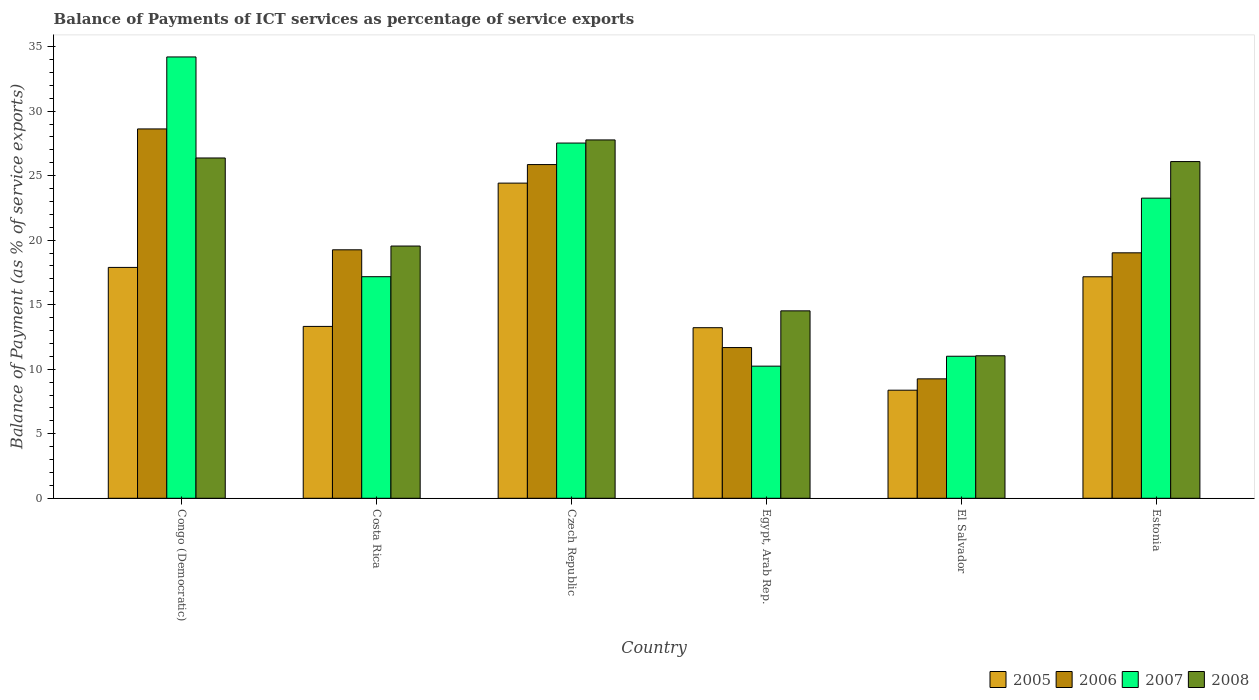Are the number of bars per tick equal to the number of legend labels?
Keep it short and to the point. Yes. How many bars are there on the 6th tick from the right?
Your answer should be very brief. 4. What is the label of the 1st group of bars from the left?
Your response must be concise. Congo (Democratic). In how many cases, is the number of bars for a given country not equal to the number of legend labels?
Make the answer very short. 0. What is the balance of payments of ICT services in 2006 in Costa Rica?
Offer a terse response. 19.25. Across all countries, what is the maximum balance of payments of ICT services in 2007?
Provide a succinct answer. 34.2. Across all countries, what is the minimum balance of payments of ICT services in 2007?
Provide a short and direct response. 10.24. In which country was the balance of payments of ICT services in 2008 maximum?
Offer a very short reply. Czech Republic. In which country was the balance of payments of ICT services in 2005 minimum?
Offer a terse response. El Salvador. What is the total balance of payments of ICT services in 2005 in the graph?
Offer a very short reply. 94.39. What is the difference between the balance of payments of ICT services in 2006 in Czech Republic and that in Estonia?
Keep it short and to the point. 6.84. What is the difference between the balance of payments of ICT services in 2008 in Congo (Democratic) and the balance of payments of ICT services in 2007 in El Salvador?
Keep it short and to the point. 15.36. What is the average balance of payments of ICT services in 2007 per country?
Your answer should be compact. 20.57. What is the difference between the balance of payments of ICT services of/in 2008 and balance of payments of ICT services of/in 2007 in Costa Rica?
Your answer should be very brief. 2.38. What is the ratio of the balance of payments of ICT services in 2008 in Czech Republic to that in Egypt, Arab Rep.?
Offer a terse response. 1.91. Is the balance of payments of ICT services in 2007 in Congo (Democratic) less than that in El Salvador?
Provide a succinct answer. No. What is the difference between the highest and the second highest balance of payments of ICT services in 2005?
Your response must be concise. 6.53. What is the difference between the highest and the lowest balance of payments of ICT services in 2006?
Provide a succinct answer. 19.37. What does the 4th bar from the right in Costa Rica represents?
Provide a short and direct response. 2005. Is it the case that in every country, the sum of the balance of payments of ICT services in 2008 and balance of payments of ICT services in 2007 is greater than the balance of payments of ICT services in 2006?
Make the answer very short. Yes. How many bars are there?
Your answer should be very brief. 24. Are all the bars in the graph horizontal?
Offer a very short reply. No. What is the difference between two consecutive major ticks on the Y-axis?
Give a very brief answer. 5. Does the graph contain any zero values?
Your response must be concise. No. Does the graph contain grids?
Offer a very short reply. No. How are the legend labels stacked?
Provide a succinct answer. Horizontal. What is the title of the graph?
Your response must be concise. Balance of Payments of ICT services as percentage of service exports. What is the label or title of the X-axis?
Offer a terse response. Country. What is the label or title of the Y-axis?
Your answer should be very brief. Balance of Payment (as % of service exports). What is the Balance of Payment (as % of service exports) of 2005 in Congo (Democratic)?
Keep it short and to the point. 17.89. What is the Balance of Payment (as % of service exports) in 2006 in Congo (Democratic)?
Your response must be concise. 28.62. What is the Balance of Payment (as % of service exports) of 2007 in Congo (Democratic)?
Offer a terse response. 34.2. What is the Balance of Payment (as % of service exports) in 2008 in Congo (Democratic)?
Your answer should be very brief. 26.37. What is the Balance of Payment (as % of service exports) in 2005 in Costa Rica?
Offer a terse response. 13.32. What is the Balance of Payment (as % of service exports) of 2006 in Costa Rica?
Offer a very short reply. 19.25. What is the Balance of Payment (as % of service exports) in 2007 in Costa Rica?
Provide a succinct answer. 17.17. What is the Balance of Payment (as % of service exports) of 2008 in Costa Rica?
Offer a terse response. 19.55. What is the Balance of Payment (as % of service exports) in 2005 in Czech Republic?
Ensure brevity in your answer.  24.42. What is the Balance of Payment (as % of service exports) in 2006 in Czech Republic?
Offer a very short reply. 25.86. What is the Balance of Payment (as % of service exports) in 2007 in Czech Republic?
Offer a very short reply. 27.53. What is the Balance of Payment (as % of service exports) of 2008 in Czech Republic?
Provide a short and direct response. 27.77. What is the Balance of Payment (as % of service exports) in 2005 in Egypt, Arab Rep.?
Give a very brief answer. 13.22. What is the Balance of Payment (as % of service exports) in 2006 in Egypt, Arab Rep.?
Provide a succinct answer. 11.68. What is the Balance of Payment (as % of service exports) of 2007 in Egypt, Arab Rep.?
Give a very brief answer. 10.24. What is the Balance of Payment (as % of service exports) of 2008 in Egypt, Arab Rep.?
Offer a very short reply. 14.52. What is the Balance of Payment (as % of service exports) in 2005 in El Salvador?
Your response must be concise. 8.38. What is the Balance of Payment (as % of service exports) of 2006 in El Salvador?
Ensure brevity in your answer.  9.25. What is the Balance of Payment (as % of service exports) in 2007 in El Salvador?
Offer a very short reply. 11.01. What is the Balance of Payment (as % of service exports) of 2008 in El Salvador?
Give a very brief answer. 11.04. What is the Balance of Payment (as % of service exports) of 2005 in Estonia?
Your answer should be compact. 17.16. What is the Balance of Payment (as % of service exports) of 2006 in Estonia?
Provide a succinct answer. 19.02. What is the Balance of Payment (as % of service exports) of 2007 in Estonia?
Make the answer very short. 23.26. What is the Balance of Payment (as % of service exports) in 2008 in Estonia?
Offer a very short reply. 26.09. Across all countries, what is the maximum Balance of Payment (as % of service exports) of 2005?
Keep it short and to the point. 24.42. Across all countries, what is the maximum Balance of Payment (as % of service exports) in 2006?
Your response must be concise. 28.62. Across all countries, what is the maximum Balance of Payment (as % of service exports) in 2007?
Ensure brevity in your answer.  34.2. Across all countries, what is the maximum Balance of Payment (as % of service exports) of 2008?
Ensure brevity in your answer.  27.77. Across all countries, what is the minimum Balance of Payment (as % of service exports) of 2005?
Keep it short and to the point. 8.38. Across all countries, what is the minimum Balance of Payment (as % of service exports) of 2006?
Offer a very short reply. 9.25. Across all countries, what is the minimum Balance of Payment (as % of service exports) of 2007?
Your answer should be compact. 10.24. Across all countries, what is the minimum Balance of Payment (as % of service exports) in 2008?
Offer a very short reply. 11.04. What is the total Balance of Payment (as % of service exports) in 2005 in the graph?
Keep it short and to the point. 94.39. What is the total Balance of Payment (as % of service exports) in 2006 in the graph?
Your answer should be very brief. 113.69. What is the total Balance of Payment (as % of service exports) of 2007 in the graph?
Offer a very short reply. 123.4. What is the total Balance of Payment (as % of service exports) in 2008 in the graph?
Make the answer very short. 125.35. What is the difference between the Balance of Payment (as % of service exports) in 2005 in Congo (Democratic) and that in Costa Rica?
Provide a short and direct response. 4.57. What is the difference between the Balance of Payment (as % of service exports) of 2006 in Congo (Democratic) and that in Costa Rica?
Keep it short and to the point. 9.37. What is the difference between the Balance of Payment (as % of service exports) of 2007 in Congo (Democratic) and that in Costa Rica?
Provide a short and direct response. 17.03. What is the difference between the Balance of Payment (as % of service exports) in 2008 in Congo (Democratic) and that in Costa Rica?
Provide a succinct answer. 6.82. What is the difference between the Balance of Payment (as % of service exports) of 2005 in Congo (Democratic) and that in Czech Republic?
Your answer should be compact. -6.53. What is the difference between the Balance of Payment (as % of service exports) of 2006 in Congo (Democratic) and that in Czech Republic?
Your response must be concise. 2.76. What is the difference between the Balance of Payment (as % of service exports) of 2007 in Congo (Democratic) and that in Czech Republic?
Your answer should be very brief. 6.67. What is the difference between the Balance of Payment (as % of service exports) of 2008 in Congo (Democratic) and that in Czech Republic?
Offer a very short reply. -1.4. What is the difference between the Balance of Payment (as % of service exports) in 2005 in Congo (Democratic) and that in Egypt, Arab Rep.?
Your answer should be compact. 4.67. What is the difference between the Balance of Payment (as % of service exports) in 2006 in Congo (Democratic) and that in Egypt, Arab Rep.?
Give a very brief answer. 16.94. What is the difference between the Balance of Payment (as % of service exports) in 2007 in Congo (Democratic) and that in Egypt, Arab Rep.?
Your response must be concise. 23.96. What is the difference between the Balance of Payment (as % of service exports) of 2008 in Congo (Democratic) and that in Egypt, Arab Rep.?
Your response must be concise. 11.85. What is the difference between the Balance of Payment (as % of service exports) in 2005 in Congo (Democratic) and that in El Salvador?
Provide a short and direct response. 9.51. What is the difference between the Balance of Payment (as % of service exports) of 2006 in Congo (Democratic) and that in El Salvador?
Your response must be concise. 19.37. What is the difference between the Balance of Payment (as % of service exports) in 2007 in Congo (Democratic) and that in El Salvador?
Give a very brief answer. 23.19. What is the difference between the Balance of Payment (as % of service exports) of 2008 in Congo (Democratic) and that in El Salvador?
Provide a succinct answer. 15.33. What is the difference between the Balance of Payment (as % of service exports) in 2005 in Congo (Democratic) and that in Estonia?
Make the answer very short. 0.73. What is the difference between the Balance of Payment (as % of service exports) in 2006 in Congo (Democratic) and that in Estonia?
Your response must be concise. 9.6. What is the difference between the Balance of Payment (as % of service exports) of 2007 in Congo (Democratic) and that in Estonia?
Offer a very short reply. 10.94. What is the difference between the Balance of Payment (as % of service exports) of 2008 in Congo (Democratic) and that in Estonia?
Your response must be concise. 0.28. What is the difference between the Balance of Payment (as % of service exports) of 2005 in Costa Rica and that in Czech Republic?
Keep it short and to the point. -11.1. What is the difference between the Balance of Payment (as % of service exports) in 2006 in Costa Rica and that in Czech Republic?
Make the answer very short. -6.6. What is the difference between the Balance of Payment (as % of service exports) of 2007 in Costa Rica and that in Czech Republic?
Ensure brevity in your answer.  -10.36. What is the difference between the Balance of Payment (as % of service exports) of 2008 in Costa Rica and that in Czech Republic?
Ensure brevity in your answer.  -8.22. What is the difference between the Balance of Payment (as % of service exports) of 2005 in Costa Rica and that in Egypt, Arab Rep.?
Provide a succinct answer. 0.1. What is the difference between the Balance of Payment (as % of service exports) in 2006 in Costa Rica and that in Egypt, Arab Rep.?
Ensure brevity in your answer.  7.57. What is the difference between the Balance of Payment (as % of service exports) in 2007 in Costa Rica and that in Egypt, Arab Rep.?
Your answer should be very brief. 6.93. What is the difference between the Balance of Payment (as % of service exports) in 2008 in Costa Rica and that in Egypt, Arab Rep.?
Offer a very short reply. 5.02. What is the difference between the Balance of Payment (as % of service exports) in 2005 in Costa Rica and that in El Salvador?
Your answer should be compact. 4.94. What is the difference between the Balance of Payment (as % of service exports) in 2006 in Costa Rica and that in El Salvador?
Give a very brief answer. 10. What is the difference between the Balance of Payment (as % of service exports) in 2007 in Costa Rica and that in El Salvador?
Your response must be concise. 6.16. What is the difference between the Balance of Payment (as % of service exports) of 2008 in Costa Rica and that in El Salvador?
Provide a succinct answer. 8.5. What is the difference between the Balance of Payment (as % of service exports) in 2005 in Costa Rica and that in Estonia?
Make the answer very short. -3.85. What is the difference between the Balance of Payment (as % of service exports) of 2006 in Costa Rica and that in Estonia?
Ensure brevity in your answer.  0.23. What is the difference between the Balance of Payment (as % of service exports) in 2007 in Costa Rica and that in Estonia?
Your answer should be compact. -6.09. What is the difference between the Balance of Payment (as % of service exports) of 2008 in Costa Rica and that in Estonia?
Keep it short and to the point. -6.55. What is the difference between the Balance of Payment (as % of service exports) of 2005 in Czech Republic and that in Egypt, Arab Rep.?
Your answer should be compact. 11.2. What is the difference between the Balance of Payment (as % of service exports) in 2006 in Czech Republic and that in Egypt, Arab Rep.?
Keep it short and to the point. 14.18. What is the difference between the Balance of Payment (as % of service exports) of 2007 in Czech Republic and that in Egypt, Arab Rep.?
Your response must be concise. 17.29. What is the difference between the Balance of Payment (as % of service exports) of 2008 in Czech Republic and that in Egypt, Arab Rep.?
Your answer should be very brief. 13.24. What is the difference between the Balance of Payment (as % of service exports) of 2005 in Czech Republic and that in El Salvador?
Keep it short and to the point. 16.05. What is the difference between the Balance of Payment (as % of service exports) in 2006 in Czech Republic and that in El Salvador?
Your answer should be very brief. 16.6. What is the difference between the Balance of Payment (as % of service exports) of 2007 in Czech Republic and that in El Salvador?
Make the answer very short. 16.52. What is the difference between the Balance of Payment (as % of service exports) in 2008 in Czech Republic and that in El Salvador?
Make the answer very short. 16.73. What is the difference between the Balance of Payment (as % of service exports) of 2005 in Czech Republic and that in Estonia?
Provide a short and direct response. 7.26. What is the difference between the Balance of Payment (as % of service exports) of 2006 in Czech Republic and that in Estonia?
Provide a succinct answer. 6.84. What is the difference between the Balance of Payment (as % of service exports) in 2007 in Czech Republic and that in Estonia?
Provide a short and direct response. 4.27. What is the difference between the Balance of Payment (as % of service exports) in 2008 in Czech Republic and that in Estonia?
Make the answer very short. 1.68. What is the difference between the Balance of Payment (as % of service exports) of 2005 in Egypt, Arab Rep. and that in El Salvador?
Your answer should be very brief. 4.84. What is the difference between the Balance of Payment (as % of service exports) in 2006 in Egypt, Arab Rep. and that in El Salvador?
Your response must be concise. 2.43. What is the difference between the Balance of Payment (as % of service exports) of 2007 in Egypt, Arab Rep. and that in El Salvador?
Provide a short and direct response. -0.77. What is the difference between the Balance of Payment (as % of service exports) in 2008 in Egypt, Arab Rep. and that in El Salvador?
Provide a succinct answer. 3.48. What is the difference between the Balance of Payment (as % of service exports) in 2005 in Egypt, Arab Rep. and that in Estonia?
Give a very brief answer. -3.95. What is the difference between the Balance of Payment (as % of service exports) of 2006 in Egypt, Arab Rep. and that in Estonia?
Offer a terse response. -7.34. What is the difference between the Balance of Payment (as % of service exports) of 2007 in Egypt, Arab Rep. and that in Estonia?
Keep it short and to the point. -13.02. What is the difference between the Balance of Payment (as % of service exports) of 2008 in Egypt, Arab Rep. and that in Estonia?
Keep it short and to the point. -11.57. What is the difference between the Balance of Payment (as % of service exports) of 2005 in El Salvador and that in Estonia?
Your answer should be compact. -8.79. What is the difference between the Balance of Payment (as % of service exports) in 2006 in El Salvador and that in Estonia?
Give a very brief answer. -9.77. What is the difference between the Balance of Payment (as % of service exports) in 2007 in El Salvador and that in Estonia?
Ensure brevity in your answer.  -12.25. What is the difference between the Balance of Payment (as % of service exports) in 2008 in El Salvador and that in Estonia?
Your answer should be compact. -15.05. What is the difference between the Balance of Payment (as % of service exports) in 2005 in Congo (Democratic) and the Balance of Payment (as % of service exports) in 2006 in Costa Rica?
Provide a short and direct response. -1.36. What is the difference between the Balance of Payment (as % of service exports) in 2005 in Congo (Democratic) and the Balance of Payment (as % of service exports) in 2007 in Costa Rica?
Ensure brevity in your answer.  0.72. What is the difference between the Balance of Payment (as % of service exports) of 2005 in Congo (Democratic) and the Balance of Payment (as % of service exports) of 2008 in Costa Rica?
Ensure brevity in your answer.  -1.66. What is the difference between the Balance of Payment (as % of service exports) of 2006 in Congo (Democratic) and the Balance of Payment (as % of service exports) of 2007 in Costa Rica?
Make the answer very short. 11.45. What is the difference between the Balance of Payment (as % of service exports) in 2006 in Congo (Democratic) and the Balance of Payment (as % of service exports) in 2008 in Costa Rica?
Give a very brief answer. 9.07. What is the difference between the Balance of Payment (as % of service exports) of 2007 in Congo (Democratic) and the Balance of Payment (as % of service exports) of 2008 in Costa Rica?
Offer a terse response. 14.65. What is the difference between the Balance of Payment (as % of service exports) in 2005 in Congo (Democratic) and the Balance of Payment (as % of service exports) in 2006 in Czech Republic?
Your answer should be compact. -7.97. What is the difference between the Balance of Payment (as % of service exports) in 2005 in Congo (Democratic) and the Balance of Payment (as % of service exports) in 2007 in Czech Republic?
Make the answer very short. -9.64. What is the difference between the Balance of Payment (as % of service exports) in 2005 in Congo (Democratic) and the Balance of Payment (as % of service exports) in 2008 in Czech Republic?
Your response must be concise. -9.88. What is the difference between the Balance of Payment (as % of service exports) of 2006 in Congo (Democratic) and the Balance of Payment (as % of service exports) of 2007 in Czech Republic?
Provide a succinct answer. 1.09. What is the difference between the Balance of Payment (as % of service exports) in 2006 in Congo (Democratic) and the Balance of Payment (as % of service exports) in 2008 in Czech Republic?
Provide a succinct answer. 0.85. What is the difference between the Balance of Payment (as % of service exports) of 2007 in Congo (Democratic) and the Balance of Payment (as % of service exports) of 2008 in Czech Republic?
Keep it short and to the point. 6.43. What is the difference between the Balance of Payment (as % of service exports) of 2005 in Congo (Democratic) and the Balance of Payment (as % of service exports) of 2006 in Egypt, Arab Rep.?
Ensure brevity in your answer.  6.21. What is the difference between the Balance of Payment (as % of service exports) in 2005 in Congo (Democratic) and the Balance of Payment (as % of service exports) in 2007 in Egypt, Arab Rep.?
Ensure brevity in your answer.  7.65. What is the difference between the Balance of Payment (as % of service exports) in 2005 in Congo (Democratic) and the Balance of Payment (as % of service exports) in 2008 in Egypt, Arab Rep.?
Keep it short and to the point. 3.37. What is the difference between the Balance of Payment (as % of service exports) of 2006 in Congo (Democratic) and the Balance of Payment (as % of service exports) of 2007 in Egypt, Arab Rep.?
Offer a terse response. 18.38. What is the difference between the Balance of Payment (as % of service exports) in 2006 in Congo (Democratic) and the Balance of Payment (as % of service exports) in 2008 in Egypt, Arab Rep.?
Your response must be concise. 14.1. What is the difference between the Balance of Payment (as % of service exports) in 2007 in Congo (Democratic) and the Balance of Payment (as % of service exports) in 2008 in Egypt, Arab Rep.?
Give a very brief answer. 19.68. What is the difference between the Balance of Payment (as % of service exports) in 2005 in Congo (Democratic) and the Balance of Payment (as % of service exports) in 2006 in El Salvador?
Ensure brevity in your answer.  8.64. What is the difference between the Balance of Payment (as % of service exports) of 2005 in Congo (Democratic) and the Balance of Payment (as % of service exports) of 2007 in El Salvador?
Your response must be concise. 6.88. What is the difference between the Balance of Payment (as % of service exports) of 2005 in Congo (Democratic) and the Balance of Payment (as % of service exports) of 2008 in El Salvador?
Offer a very short reply. 6.85. What is the difference between the Balance of Payment (as % of service exports) of 2006 in Congo (Democratic) and the Balance of Payment (as % of service exports) of 2007 in El Salvador?
Keep it short and to the point. 17.61. What is the difference between the Balance of Payment (as % of service exports) in 2006 in Congo (Democratic) and the Balance of Payment (as % of service exports) in 2008 in El Salvador?
Ensure brevity in your answer.  17.58. What is the difference between the Balance of Payment (as % of service exports) of 2007 in Congo (Democratic) and the Balance of Payment (as % of service exports) of 2008 in El Salvador?
Make the answer very short. 23.16. What is the difference between the Balance of Payment (as % of service exports) of 2005 in Congo (Democratic) and the Balance of Payment (as % of service exports) of 2006 in Estonia?
Your response must be concise. -1.13. What is the difference between the Balance of Payment (as % of service exports) of 2005 in Congo (Democratic) and the Balance of Payment (as % of service exports) of 2007 in Estonia?
Ensure brevity in your answer.  -5.37. What is the difference between the Balance of Payment (as % of service exports) of 2005 in Congo (Democratic) and the Balance of Payment (as % of service exports) of 2008 in Estonia?
Your answer should be compact. -8.2. What is the difference between the Balance of Payment (as % of service exports) of 2006 in Congo (Democratic) and the Balance of Payment (as % of service exports) of 2007 in Estonia?
Your answer should be very brief. 5.36. What is the difference between the Balance of Payment (as % of service exports) in 2006 in Congo (Democratic) and the Balance of Payment (as % of service exports) in 2008 in Estonia?
Ensure brevity in your answer.  2.53. What is the difference between the Balance of Payment (as % of service exports) in 2007 in Congo (Democratic) and the Balance of Payment (as % of service exports) in 2008 in Estonia?
Give a very brief answer. 8.11. What is the difference between the Balance of Payment (as % of service exports) in 2005 in Costa Rica and the Balance of Payment (as % of service exports) in 2006 in Czech Republic?
Make the answer very short. -12.54. What is the difference between the Balance of Payment (as % of service exports) of 2005 in Costa Rica and the Balance of Payment (as % of service exports) of 2007 in Czech Republic?
Give a very brief answer. -14.21. What is the difference between the Balance of Payment (as % of service exports) of 2005 in Costa Rica and the Balance of Payment (as % of service exports) of 2008 in Czech Republic?
Make the answer very short. -14.45. What is the difference between the Balance of Payment (as % of service exports) of 2006 in Costa Rica and the Balance of Payment (as % of service exports) of 2007 in Czech Republic?
Give a very brief answer. -8.27. What is the difference between the Balance of Payment (as % of service exports) in 2006 in Costa Rica and the Balance of Payment (as % of service exports) in 2008 in Czech Republic?
Offer a terse response. -8.51. What is the difference between the Balance of Payment (as % of service exports) in 2007 in Costa Rica and the Balance of Payment (as % of service exports) in 2008 in Czech Republic?
Your answer should be compact. -10.6. What is the difference between the Balance of Payment (as % of service exports) of 2005 in Costa Rica and the Balance of Payment (as % of service exports) of 2006 in Egypt, Arab Rep.?
Ensure brevity in your answer.  1.64. What is the difference between the Balance of Payment (as % of service exports) in 2005 in Costa Rica and the Balance of Payment (as % of service exports) in 2007 in Egypt, Arab Rep.?
Your answer should be compact. 3.08. What is the difference between the Balance of Payment (as % of service exports) of 2005 in Costa Rica and the Balance of Payment (as % of service exports) of 2008 in Egypt, Arab Rep.?
Make the answer very short. -1.21. What is the difference between the Balance of Payment (as % of service exports) of 2006 in Costa Rica and the Balance of Payment (as % of service exports) of 2007 in Egypt, Arab Rep.?
Offer a terse response. 9.02. What is the difference between the Balance of Payment (as % of service exports) of 2006 in Costa Rica and the Balance of Payment (as % of service exports) of 2008 in Egypt, Arab Rep.?
Your response must be concise. 4.73. What is the difference between the Balance of Payment (as % of service exports) in 2007 in Costa Rica and the Balance of Payment (as % of service exports) in 2008 in Egypt, Arab Rep.?
Your answer should be very brief. 2.65. What is the difference between the Balance of Payment (as % of service exports) in 2005 in Costa Rica and the Balance of Payment (as % of service exports) in 2006 in El Salvador?
Offer a terse response. 4.06. What is the difference between the Balance of Payment (as % of service exports) in 2005 in Costa Rica and the Balance of Payment (as % of service exports) in 2007 in El Salvador?
Keep it short and to the point. 2.31. What is the difference between the Balance of Payment (as % of service exports) in 2005 in Costa Rica and the Balance of Payment (as % of service exports) in 2008 in El Salvador?
Offer a terse response. 2.27. What is the difference between the Balance of Payment (as % of service exports) of 2006 in Costa Rica and the Balance of Payment (as % of service exports) of 2007 in El Salvador?
Provide a succinct answer. 8.25. What is the difference between the Balance of Payment (as % of service exports) in 2006 in Costa Rica and the Balance of Payment (as % of service exports) in 2008 in El Salvador?
Provide a short and direct response. 8.21. What is the difference between the Balance of Payment (as % of service exports) in 2007 in Costa Rica and the Balance of Payment (as % of service exports) in 2008 in El Salvador?
Your answer should be very brief. 6.13. What is the difference between the Balance of Payment (as % of service exports) in 2005 in Costa Rica and the Balance of Payment (as % of service exports) in 2006 in Estonia?
Keep it short and to the point. -5.7. What is the difference between the Balance of Payment (as % of service exports) of 2005 in Costa Rica and the Balance of Payment (as % of service exports) of 2007 in Estonia?
Provide a short and direct response. -9.94. What is the difference between the Balance of Payment (as % of service exports) in 2005 in Costa Rica and the Balance of Payment (as % of service exports) in 2008 in Estonia?
Your answer should be compact. -12.77. What is the difference between the Balance of Payment (as % of service exports) in 2006 in Costa Rica and the Balance of Payment (as % of service exports) in 2007 in Estonia?
Ensure brevity in your answer.  -4. What is the difference between the Balance of Payment (as % of service exports) in 2006 in Costa Rica and the Balance of Payment (as % of service exports) in 2008 in Estonia?
Give a very brief answer. -6.84. What is the difference between the Balance of Payment (as % of service exports) in 2007 in Costa Rica and the Balance of Payment (as % of service exports) in 2008 in Estonia?
Your answer should be very brief. -8.92. What is the difference between the Balance of Payment (as % of service exports) of 2005 in Czech Republic and the Balance of Payment (as % of service exports) of 2006 in Egypt, Arab Rep.?
Give a very brief answer. 12.74. What is the difference between the Balance of Payment (as % of service exports) in 2005 in Czech Republic and the Balance of Payment (as % of service exports) in 2007 in Egypt, Arab Rep.?
Offer a terse response. 14.18. What is the difference between the Balance of Payment (as % of service exports) of 2005 in Czech Republic and the Balance of Payment (as % of service exports) of 2008 in Egypt, Arab Rep.?
Your answer should be compact. 9.9. What is the difference between the Balance of Payment (as % of service exports) in 2006 in Czech Republic and the Balance of Payment (as % of service exports) in 2007 in Egypt, Arab Rep.?
Your answer should be very brief. 15.62. What is the difference between the Balance of Payment (as % of service exports) of 2006 in Czech Republic and the Balance of Payment (as % of service exports) of 2008 in Egypt, Arab Rep.?
Offer a very short reply. 11.34. What is the difference between the Balance of Payment (as % of service exports) in 2007 in Czech Republic and the Balance of Payment (as % of service exports) in 2008 in Egypt, Arab Rep.?
Offer a very short reply. 13. What is the difference between the Balance of Payment (as % of service exports) of 2005 in Czech Republic and the Balance of Payment (as % of service exports) of 2006 in El Salvador?
Provide a short and direct response. 15.17. What is the difference between the Balance of Payment (as % of service exports) of 2005 in Czech Republic and the Balance of Payment (as % of service exports) of 2007 in El Salvador?
Offer a terse response. 13.42. What is the difference between the Balance of Payment (as % of service exports) of 2005 in Czech Republic and the Balance of Payment (as % of service exports) of 2008 in El Salvador?
Give a very brief answer. 13.38. What is the difference between the Balance of Payment (as % of service exports) of 2006 in Czech Republic and the Balance of Payment (as % of service exports) of 2007 in El Salvador?
Your response must be concise. 14.85. What is the difference between the Balance of Payment (as % of service exports) in 2006 in Czech Republic and the Balance of Payment (as % of service exports) in 2008 in El Salvador?
Ensure brevity in your answer.  14.82. What is the difference between the Balance of Payment (as % of service exports) in 2007 in Czech Republic and the Balance of Payment (as % of service exports) in 2008 in El Salvador?
Offer a terse response. 16.48. What is the difference between the Balance of Payment (as % of service exports) in 2005 in Czech Republic and the Balance of Payment (as % of service exports) in 2006 in Estonia?
Offer a terse response. 5.4. What is the difference between the Balance of Payment (as % of service exports) in 2005 in Czech Republic and the Balance of Payment (as % of service exports) in 2007 in Estonia?
Ensure brevity in your answer.  1.16. What is the difference between the Balance of Payment (as % of service exports) in 2005 in Czech Republic and the Balance of Payment (as % of service exports) in 2008 in Estonia?
Offer a terse response. -1.67. What is the difference between the Balance of Payment (as % of service exports) in 2006 in Czech Republic and the Balance of Payment (as % of service exports) in 2007 in Estonia?
Give a very brief answer. 2.6. What is the difference between the Balance of Payment (as % of service exports) in 2006 in Czech Republic and the Balance of Payment (as % of service exports) in 2008 in Estonia?
Your answer should be very brief. -0.23. What is the difference between the Balance of Payment (as % of service exports) of 2007 in Czech Republic and the Balance of Payment (as % of service exports) of 2008 in Estonia?
Offer a terse response. 1.43. What is the difference between the Balance of Payment (as % of service exports) in 2005 in Egypt, Arab Rep. and the Balance of Payment (as % of service exports) in 2006 in El Salvador?
Make the answer very short. 3.96. What is the difference between the Balance of Payment (as % of service exports) of 2005 in Egypt, Arab Rep. and the Balance of Payment (as % of service exports) of 2007 in El Salvador?
Offer a terse response. 2.21. What is the difference between the Balance of Payment (as % of service exports) of 2005 in Egypt, Arab Rep. and the Balance of Payment (as % of service exports) of 2008 in El Salvador?
Keep it short and to the point. 2.18. What is the difference between the Balance of Payment (as % of service exports) of 2006 in Egypt, Arab Rep. and the Balance of Payment (as % of service exports) of 2007 in El Salvador?
Your response must be concise. 0.67. What is the difference between the Balance of Payment (as % of service exports) in 2006 in Egypt, Arab Rep. and the Balance of Payment (as % of service exports) in 2008 in El Salvador?
Make the answer very short. 0.64. What is the difference between the Balance of Payment (as % of service exports) in 2007 in Egypt, Arab Rep. and the Balance of Payment (as % of service exports) in 2008 in El Salvador?
Provide a succinct answer. -0.8. What is the difference between the Balance of Payment (as % of service exports) of 2005 in Egypt, Arab Rep. and the Balance of Payment (as % of service exports) of 2006 in Estonia?
Offer a terse response. -5.8. What is the difference between the Balance of Payment (as % of service exports) of 2005 in Egypt, Arab Rep. and the Balance of Payment (as % of service exports) of 2007 in Estonia?
Offer a terse response. -10.04. What is the difference between the Balance of Payment (as % of service exports) of 2005 in Egypt, Arab Rep. and the Balance of Payment (as % of service exports) of 2008 in Estonia?
Offer a very short reply. -12.87. What is the difference between the Balance of Payment (as % of service exports) in 2006 in Egypt, Arab Rep. and the Balance of Payment (as % of service exports) in 2007 in Estonia?
Make the answer very short. -11.58. What is the difference between the Balance of Payment (as % of service exports) in 2006 in Egypt, Arab Rep. and the Balance of Payment (as % of service exports) in 2008 in Estonia?
Your response must be concise. -14.41. What is the difference between the Balance of Payment (as % of service exports) of 2007 in Egypt, Arab Rep. and the Balance of Payment (as % of service exports) of 2008 in Estonia?
Provide a short and direct response. -15.85. What is the difference between the Balance of Payment (as % of service exports) of 2005 in El Salvador and the Balance of Payment (as % of service exports) of 2006 in Estonia?
Keep it short and to the point. -10.65. What is the difference between the Balance of Payment (as % of service exports) of 2005 in El Salvador and the Balance of Payment (as % of service exports) of 2007 in Estonia?
Make the answer very short. -14.88. What is the difference between the Balance of Payment (as % of service exports) of 2005 in El Salvador and the Balance of Payment (as % of service exports) of 2008 in Estonia?
Offer a terse response. -17.72. What is the difference between the Balance of Payment (as % of service exports) in 2006 in El Salvador and the Balance of Payment (as % of service exports) in 2007 in Estonia?
Offer a very short reply. -14. What is the difference between the Balance of Payment (as % of service exports) of 2006 in El Salvador and the Balance of Payment (as % of service exports) of 2008 in Estonia?
Provide a short and direct response. -16.84. What is the difference between the Balance of Payment (as % of service exports) in 2007 in El Salvador and the Balance of Payment (as % of service exports) in 2008 in Estonia?
Keep it short and to the point. -15.09. What is the average Balance of Payment (as % of service exports) of 2005 per country?
Make the answer very short. 15.73. What is the average Balance of Payment (as % of service exports) of 2006 per country?
Provide a short and direct response. 18.95. What is the average Balance of Payment (as % of service exports) in 2007 per country?
Your answer should be very brief. 20.57. What is the average Balance of Payment (as % of service exports) of 2008 per country?
Provide a succinct answer. 20.89. What is the difference between the Balance of Payment (as % of service exports) of 2005 and Balance of Payment (as % of service exports) of 2006 in Congo (Democratic)?
Offer a terse response. -10.73. What is the difference between the Balance of Payment (as % of service exports) in 2005 and Balance of Payment (as % of service exports) in 2007 in Congo (Democratic)?
Offer a terse response. -16.31. What is the difference between the Balance of Payment (as % of service exports) in 2005 and Balance of Payment (as % of service exports) in 2008 in Congo (Democratic)?
Ensure brevity in your answer.  -8.48. What is the difference between the Balance of Payment (as % of service exports) in 2006 and Balance of Payment (as % of service exports) in 2007 in Congo (Democratic)?
Make the answer very short. -5.58. What is the difference between the Balance of Payment (as % of service exports) in 2006 and Balance of Payment (as % of service exports) in 2008 in Congo (Democratic)?
Make the answer very short. 2.25. What is the difference between the Balance of Payment (as % of service exports) in 2007 and Balance of Payment (as % of service exports) in 2008 in Congo (Democratic)?
Keep it short and to the point. 7.83. What is the difference between the Balance of Payment (as % of service exports) in 2005 and Balance of Payment (as % of service exports) in 2006 in Costa Rica?
Ensure brevity in your answer.  -5.94. What is the difference between the Balance of Payment (as % of service exports) in 2005 and Balance of Payment (as % of service exports) in 2007 in Costa Rica?
Your answer should be compact. -3.85. What is the difference between the Balance of Payment (as % of service exports) of 2005 and Balance of Payment (as % of service exports) of 2008 in Costa Rica?
Offer a very short reply. -6.23. What is the difference between the Balance of Payment (as % of service exports) of 2006 and Balance of Payment (as % of service exports) of 2007 in Costa Rica?
Your response must be concise. 2.08. What is the difference between the Balance of Payment (as % of service exports) of 2006 and Balance of Payment (as % of service exports) of 2008 in Costa Rica?
Keep it short and to the point. -0.29. What is the difference between the Balance of Payment (as % of service exports) of 2007 and Balance of Payment (as % of service exports) of 2008 in Costa Rica?
Keep it short and to the point. -2.38. What is the difference between the Balance of Payment (as % of service exports) in 2005 and Balance of Payment (as % of service exports) in 2006 in Czech Republic?
Your answer should be very brief. -1.44. What is the difference between the Balance of Payment (as % of service exports) in 2005 and Balance of Payment (as % of service exports) in 2007 in Czech Republic?
Keep it short and to the point. -3.1. What is the difference between the Balance of Payment (as % of service exports) of 2005 and Balance of Payment (as % of service exports) of 2008 in Czech Republic?
Your response must be concise. -3.35. What is the difference between the Balance of Payment (as % of service exports) in 2006 and Balance of Payment (as % of service exports) in 2007 in Czech Republic?
Your answer should be very brief. -1.67. What is the difference between the Balance of Payment (as % of service exports) of 2006 and Balance of Payment (as % of service exports) of 2008 in Czech Republic?
Provide a succinct answer. -1.91. What is the difference between the Balance of Payment (as % of service exports) of 2007 and Balance of Payment (as % of service exports) of 2008 in Czech Republic?
Keep it short and to the point. -0.24. What is the difference between the Balance of Payment (as % of service exports) in 2005 and Balance of Payment (as % of service exports) in 2006 in Egypt, Arab Rep.?
Your answer should be very brief. 1.54. What is the difference between the Balance of Payment (as % of service exports) in 2005 and Balance of Payment (as % of service exports) in 2007 in Egypt, Arab Rep.?
Make the answer very short. 2.98. What is the difference between the Balance of Payment (as % of service exports) in 2005 and Balance of Payment (as % of service exports) in 2008 in Egypt, Arab Rep.?
Provide a succinct answer. -1.3. What is the difference between the Balance of Payment (as % of service exports) of 2006 and Balance of Payment (as % of service exports) of 2007 in Egypt, Arab Rep.?
Keep it short and to the point. 1.44. What is the difference between the Balance of Payment (as % of service exports) in 2006 and Balance of Payment (as % of service exports) in 2008 in Egypt, Arab Rep.?
Ensure brevity in your answer.  -2.84. What is the difference between the Balance of Payment (as % of service exports) in 2007 and Balance of Payment (as % of service exports) in 2008 in Egypt, Arab Rep.?
Offer a very short reply. -4.29. What is the difference between the Balance of Payment (as % of service exports) in 2005 and Balance of Payment (as % of service exports) in 2006 in El Salvador?
Provide a short and direct response. -0.88. What is the difference between the Balance of Payment (as % of service exports) in 2005 and Balance of Payment (as % of service exports) in 2007 in El Salvador?
Provide a succinct answer. -2.63. What is the difference between the Balance of Payment (as % of service exports) in 2005 and Balance of Payment (as % of service exports) in 2008 in El Salvador?
Keep it short and to the point. -2.67. What is the difference between the Balance of Payment (as % of service exports) of 2006 and Balance of Payment (as % of service exports) of 2007 in El Salvador?
Make the answer very short. -1.75. What is the difference between the Balance of Payment (as % of service exports) in 2006 and Balance of Payment (as % of service exports) in 2008 in El Salvador?
Your response must be concise. -1.79. What is the difference between the Balance of Payment (as % of service exports) in 2007 and Balance of Payment (as % of service exports) in 2008 in El Salvador?
Give a very brief answer. -0.04. What is the difference between the Balance of Payment (as % of service exports) of 2005 and Balance of Payment (as % of service exports) of 2006 in Estonia?
Offer a terse response. -1.86. What is the difference between the Balance of Payment (as % of service exports) in 2005 and Balance of Payment (as % of service exports) in 2007 in Estonia?
Provide a succinct answer. -6.09. What is the difference between the Balance of Payment (as % of service exports) in 2005 and Balance of Payment (as % of service exports) in 2008 in Estonia?
Provide a short and direct response. -8.93. What is the difference between the Balance of Payment (as % of service exports) in 2006 and Balance of Payment (as % of service exports) in 2007 in Estonia?
Ensure brevity in your answer.  -4.24. What is the difference between the Balance of Payment (as % of service exports) in 2006 and Balance of Payment (as % of service exports) in 2008 in Estonia?
Your response must be concise. -7.07. What is the difference between the Balance of Payment (as % of service exports) of 2007 and Balance of Payment (as % of service exports) of 2008 in Estonia?
Ensure brevity in your answer.  -2.84. What is the ratio of the Balance of Payment (as % of service exports) in 2005 in Congo (Democratic) to that in Costa Rica?
Ensure brevity in your answer.  1.34. What is the ratio of the Balance of Payment (as % of service exports) in 2006 in Congo (Democratic) to that in Costa Rica?
Offer a terse response. 1.49. What is the ratio of the Balance of Payment (as % of service exports) in 2007 in Congo (Democratic) to that in Costa Rica?
Make the answer very short. 1.99. What is the ratio of the Balance of Payment (as % of service exports) in 2008 in Congo (Democratic) to that in Costa Rica?
Your answer should be very brief. 1.35. What is the ratio of the Balance of Payment (as % of service exports) in 2005 in Congo (Democratic) to that in Czech Republic?
Your response must be concise. 0.73. What is the ratio of the Balance of Payment (as % of service exports) of 2006 in Congo (Democratic) to that in Czech Republic?
Provide a succinct answer. 1.11. What is the ratio of the Balance of Payment (as % of service exports) of 2007 in Congo (Democratic) to that in Czech Republic?
Provide a succinct answer. 1.24. What is the ratio of the Balance of Payment (as % of service exports) in 2008 in Congo (Democratic) to that in Czech Republic?
Offer a terse response. 0.95. What is the ratio of the Balance of Payment (as % of service exports) in 2005 in Congo (Democratic) to that in Egypt, Arab Rep.?
Provide a succinct answer. 1.35. What is the ratio of the Balance of Payment (as % of service exports) of 2006 in Congo (Democratic) to that in Egypt, Arab Rep.?
Your response must be concise. 2.45. What is the ratio of the Balance of Payment (as % of service exports) of 2007 in Congo (Democratic) to that in Egypt, Arab Rep.?
Your answer should be very brief. 3.34. What is the ratio of the Balance of Payment (as % of service exports) in 2008 in Congo (Democratic) to that in Egypt, Arab Rep.?
Offer a terse response. 1.82. What is the ratio of the Balance of Payment (as % of service exports) in 2005 in Congo (Democratic) to that in El Salvador?
Keep it short and to the point. 2.14. What is the ratio of the Balance of Payment (as % of service exports) of 2006 in Congo (Democratic) to that in El Salvador?
Offer a terse response. 3.09. What is the ratio of the Balance of Payment (as % of service exports) in 2007 in Congo (Democratic) to that in El Salvador?
Your answer should be very brief. 3.11. What is the ratio of the Balance of Payment (as % of service exports) in 2008 in Congo (Democratic) to that in El Salvador?
Provide a succinct answer. 2.39. What is the ratio of the Balance of Payment (as % of service exports) of 2005 in Congo (Democratic) to that in Estonia?
Your response must be concise. 1.04. What is the ratio of the Balance of Payment (as % of service exports) in 2006 in Congo (Democratic) to that in Estonia?
Offer a very short reply. 1.5. What is the ratio of the Balance of Payment (as % of service exports) in 2007 in Congo (Democratic) to that in Estonia?
Your answer should be compact. 1.47. What is the ratio of the Balance of Payment (as % of service exports) of 2008 in Congo (Democratic) to that in Estonia?
Provide a short and direct response. 1.01. What is the ratio of the Balance of Payment (as % of service exports) of 2005 in Costa Rica to that in Czech Republic?
Ensure brevity in your answer.  0.55. What is the ratio of the Balance of Payment (as % of service exports) in 2006 in Costa Rica to that in Czech Republic?
Your answer should be very brief. 0.74. What is the ratio of the Balance of Payment (as % of service exports) in 2007 in Costa Rica to that in Czech Republic?
Your answer should be very brief. 0.62. What is the ratio of the Balance of Payment (as % of service exports) in 2008 in Costa Rica to that in Czech Republic?
Keep it short and to the point. 0.7. What is the ratio of the Balance of Payment (as % of service exports) of 2005 in Costa Rica to that in Egypt, Arab Rep.?
Offer a terse response. 1.01. What is the ratio of the Balance of Payment (as % of service exports) of 2006 in Costa Rica to that in Egypt, Arab Rep.?
Provide a succinct answer. 1.65. What is the ratio of the Balance of Payment (as % of service exports) of 2007 in Costa Rica to that in Egypt, Arab Rep.?
Offer a terse response. 1.68. What is the ratio of the Balance of Payment (as % of service exports) in 2008 in Costa Rica to that in Egypt, Arab Rep.?
Keep it short and to the point. 1.35. What is the ratio of the Balance of Payment (as % of service exports) in 2005 in Costa Rica to that in El Salvador?
Your response must be concise. 1.59. What is the ratio of the Balance of Payment (as % of service exports) of 2006 in Costa Rica to that in El Salvador?
Provide a succinct answer. 2.08. What is the ratio of the Balance of Payment (as % of service exports) of 2007 in Costa Rica to that in El Salvador?
Provide a succinct answer. 1.56. What is the ratio of the Balance of Payment (as % of service exports) of 2008 in Costa Rica to that in El Salvador?
Provide a succinct answer. 1.77. What is the ratio of the Balance of Payment (as % of service exports) of 2005 in Costa Rica to that in Estonia?
Provide a short and direct response. 0.78. What is the ratio of the Balance of Payment (as % of service exports) of 2006 in Costa Rica to that in Estonia?
Offer a terse response. 1.01. What is the ratio of the Balance of Payment (as % of service exports) of 2007 in Costa Rica to that in Estonia?
Provide a succinct answer. 0.74. What is the ratio of the Balance of Payment (as % of service exports) in 2008 in Costa Rica to that in Estonia?
Give a very brief answer. 0.75. What is the ratio of the Balance of Payment (as % of service exports) of 2005 in Czech Republic to that in Egypt, Arab Rep.?
Ensure brevity in your answer.  1.85. What is the ratio of the Balance of Payment (as % of service exports) in 2006 in Czech Republic to that in Egypt, Arab Rep.?
Offer a terse response. 2.21. What is the ratio of the Balance of Payment (as % of service exports) in 2007 in Czech Republic to that in Egypt, Arab Rep.?
Provide a succinct answer. 2.69. What is the ratio of the Balance of Payment (as % of service exports) of 2008 in Czech Republic to that in Egypt, Arab Rep.?
Offer a very short reply. 1.91. What is the ratio of the Balance of Payment (as % of service exports) in 2005 in Czech Republic to that in El Salvador?
Give a very brief answer. 2.92. What is the ratio of the Balance of Payment (as % of service exports) of 2006 in Czech Republic to that in El Salvador?
Offer a very short reply. 2.79. What is the ratio of the Balance of Payment (as % of service exports) of 2007 in Czech Republic to that in El Salvador?
Offer a terse response. 2.5. What is the ratio of the Balance of Payment (as % of service exports) in 2008 in Czech Republic to that in El Salvador?
Make the answer very short. 2.51. What is the ratio of the Balance of Payment (as % of service exports) of 2005 in Czech Republic to that in Estonia?
Your answer should be very brief. 1.42. What is the ratio of the Balance of Payment (as % of service exports) of 2006 in Czech Republic to that in Estonia?
Make the answer very short. 1.36. What is the ratio of the Balance of Payment (as % of service exports) in 2007 in Czech Republic to that in Estonia?
Give a very brief answer. 1.18. What is the ratio of the Balance of Payment (as % of service exports) of 2008 in Czech Republic to that in Estonia?
Offer a very short reply. 1.06. What is the ratio of the Balance of Payment (as % of service exports) in 2005 in Egypt, Arab Rep. to that in El Salvador?
Your answer should be very brief. 1.58. What is the ratio of the Balance of Payment (as % of service exports) of 2006 in Egypt, Arab Rep. to that in El Salvador?
Offer a very short reply. 1.26. What is the ratio of the Balance of Payment (as % of service exports) of 2007 in Egypt, Arab Rep. to that in El Salvador?
Ensure brevity in your answer.  0.93. What is the ratio of the Balance of Payment (as % of service exports) of 2008 in Egypt, Arab Rep. to that in El Salvador?
Make the answer very short. 1.32. What is the ratio of the Balance of Payment (as % of service exports) of 2005 in Egypt, Arab Rep. to that in Estonia?
Make the answer very short. 0.77. What is the ratio of the Balance of Payment (as % of service exports) in 2006 in Egypt, Arab Rep. to that in Estonia?
Ensure brevity in your answer.  0.61. What is the ratio of the Balance of Payment (as % of service exports) in 2007 in Egypt, Arab Rep. to that in Estonia?
Give a very brief answer. 0.44. What is the ratio of the Balance of Payment (as % of service exports) in 2008 in Egypt, Arab Rep. to that in Estonia?
Ensure brevity in your answer.  0.56. What is the ratio of the Balance of Payment (as % of service exports) of 2005 in El Salvador to that in Estonia?
Provide a succinct answer. 0.49. What is the ratio of the Balance of Payment (as % of service exports) of 2006 in El Salvador to that in Estonia?
Make the answer very short. 0.49. What is the ratio of the Balance of Payment (as % of service exports) in 2007 in El Salvador to that in Estonia?
Ensure brevity in your answer.  0.47. What is the ratio of the Balance of Payment (as % of service exports) of 2008 in El Salvador to that in Estonia?
Give a very brief answer. 0.42. What is the difference between the highest and the second highest Balance of Payment (as % of service exports) in 2005?
Keep it short and to the point. 6.53. What is the difference between the highest and the second highest Balance of Payment (as % of service exports) in 2006?
Offer a very short reply. 2.76. What is the difference between the highest and the second highest Balance of Payment (as % of service exports) in 2007?
Offer a terse response. 6.67. What is the difference between the highest and the second highest Balance of Payment (as % of service exports) of 2008?
Provide a short and direct response. 1.4. What is the difference between the highest and the lowest Balance of Payment (as % of service exports) of 2005?
Your answer should be compact. 16.05. What is the difference between the highest and the lowest Balance of Payment (as % of service exports) in 2006?
Offer a very short reply. 19.37. What is the difference between the highest and the lowest Balance of Payment (as % of service exports) of 2007?
Provide a succinct answer. 23.96. What is the difference between the highest and the lowest Balance of Payment (as % of service exports) of 2008?
Offer a very short reply. 16.73. 